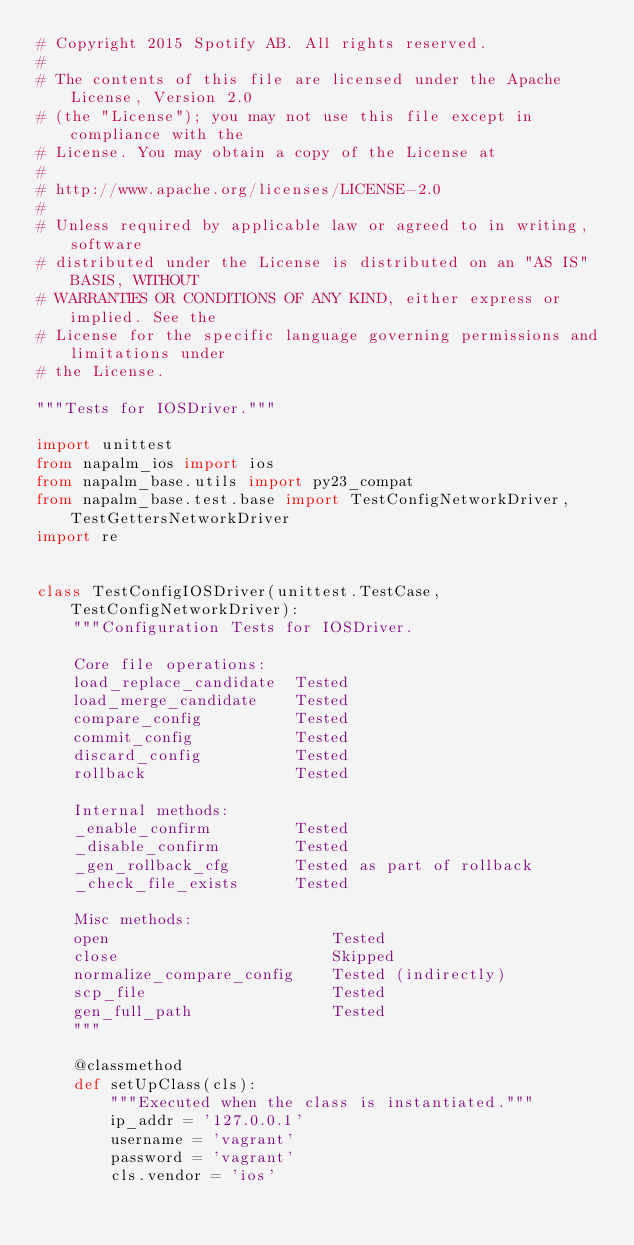<code> <loc_0><loc_0><loc_500><loc_500><_Python_># Copyright 2015 Spotify AB. All rights reserved.
#
# The contents of this file are licensed under the Apache License, Version 2.0
# (the "License"); you may not use this file except in compliance with the
# License. You may obtain a copy of the License at
#
# http://www.apache.org/licenses/LICENSE-2.0
#
# Unless required by applicable law or agreed to in writing, software
# distributed under the License is distributed on an "AS IS" BASIS, WITHOUT
# WARRANTIES OR CONDITIONS OF ANY KIND, either express or implied. See the
# License for the specific language governing permissions and limitations under
# the License.

"""Tests for IOSDriver."""

import unittest
from napalm_ios import ios
from napalm_base.utils import py23_compat
from napalm_base.test.base import TestConfigNetworkDriver, TestGettersNetworkDriver
import re


class TestConfigIOSDriver(unittest.TestCase, TestConfigNetworkDriver):
    """Configuration Tests for IOSDriver.

    Core file operations:
    load_replace_candidate  Tested
    load_merge_candidate    Tested
    compare_config          Tested
    commit_config           Tested
    discard_config          Tested
    rollback                Tested

    Internal methods:
    _enable_confirm         Tested
    _disable_confirm        Tested
    _gen_rollback_cfg       Tested as part of rollback
    _check_file_exists      Tested

    Misc methods:
    open                        Tested
    close                       Skipped
    normalize_compare_config    Tested (indirectly)
    scp_file                    Tested
    gen_full_path               Tested
    """

    @classmethod
    def setUpClass(cls):
        """Executed when the class is instantiated."""
        ip_addr = '127.0.0.1'
        username = 'vagrant'
        password = 'vagrant'
        cls.vendor = 'ios'</code> 